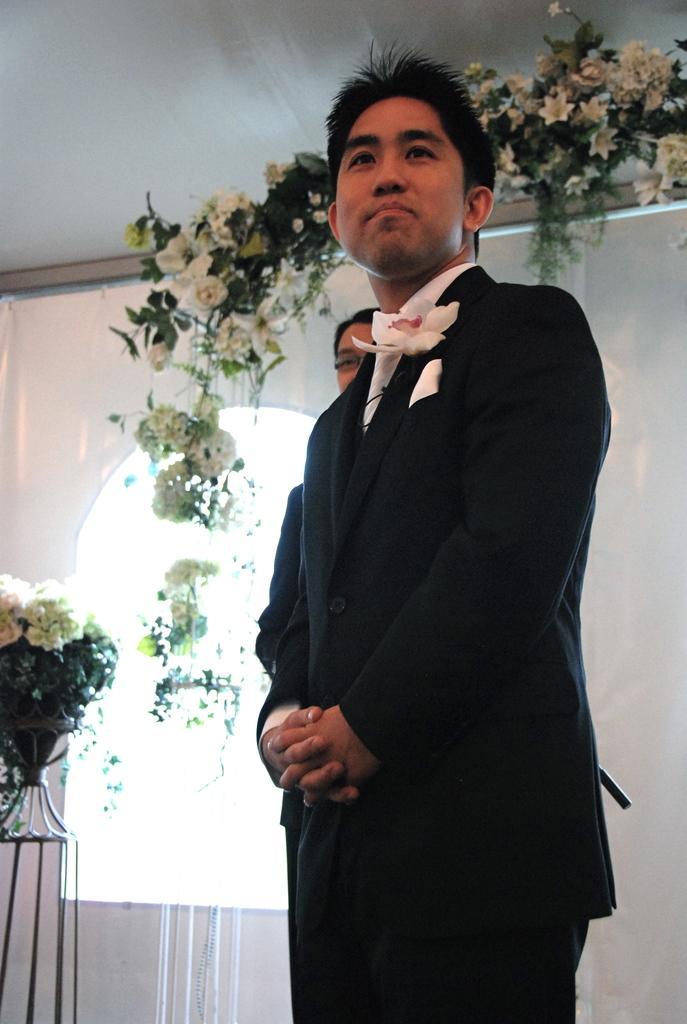Please provide a concise description of this image. There is a person in black color suit, smiling and standing. In the background, there is another person who is standing, there is a pot plant having flowers, there are plants having flowers, there is a window and a white wall. 